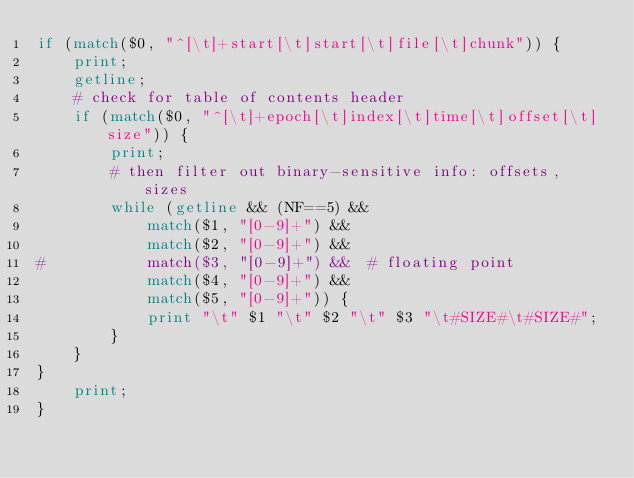<code> <loc_0><loc_0><loc_500><loc_500><_Awk_>if (match($0, "^[\t]+start[\t]start[\t]file[\t]chunk")) {
	print;
	getline;
	# check for table of contents header
	if (match($0, "^[\t]+epoch[\t]index[\t]time[\t]offset[\t]size")) {
		print;
		# then filter out binary-sensitive info: offsets, sizes
		while (getline && (NF==5) &&
			match($1, "[0-9]+") &&
			match($2, "[0-9]+") &&
#			match($3, "[0-9]+") &&	# floating point
			match($4, "[0-9]+") &&
			match($5, "[0-9]+")) {
			print "\t" $1 "\t" $2 "\t" $3 "\t#SIZE#\t#SIZE#";
		}
	}
}
	print;
}

</code> 